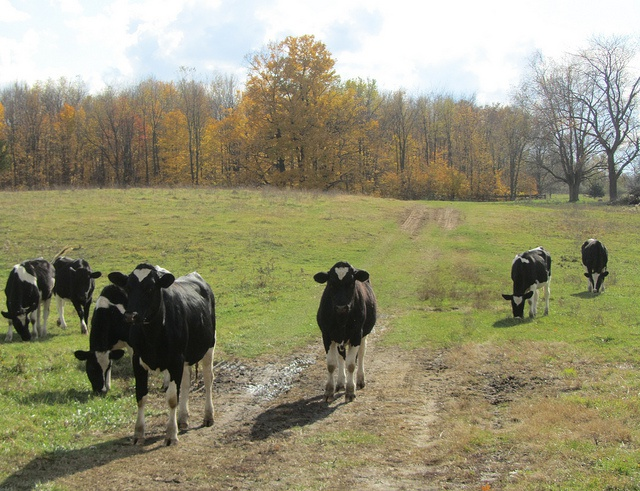Describe the objects in this image and their specific colors. I can see cow in white, black, gray, and darkgray tones, cow in white, black, and gray tones, cow in white, black, gray, olive, and darkgreen tones, cow in white, black, gray, olive, and darkgreen tones, and cow in white, black, gray, and darkgray tones in this image. 